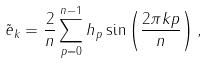Convert formula to latex. <formula><loc_0><loc_0><loc_500><loc_500>\tilde { e } _ { k } = \frac { 2 } { n } \sum _ { p = 0 } ^ { n - 1 } h _ { p } \sin \left ( \frac { 2 \pi k p } { n } \right ) ,</formula> 